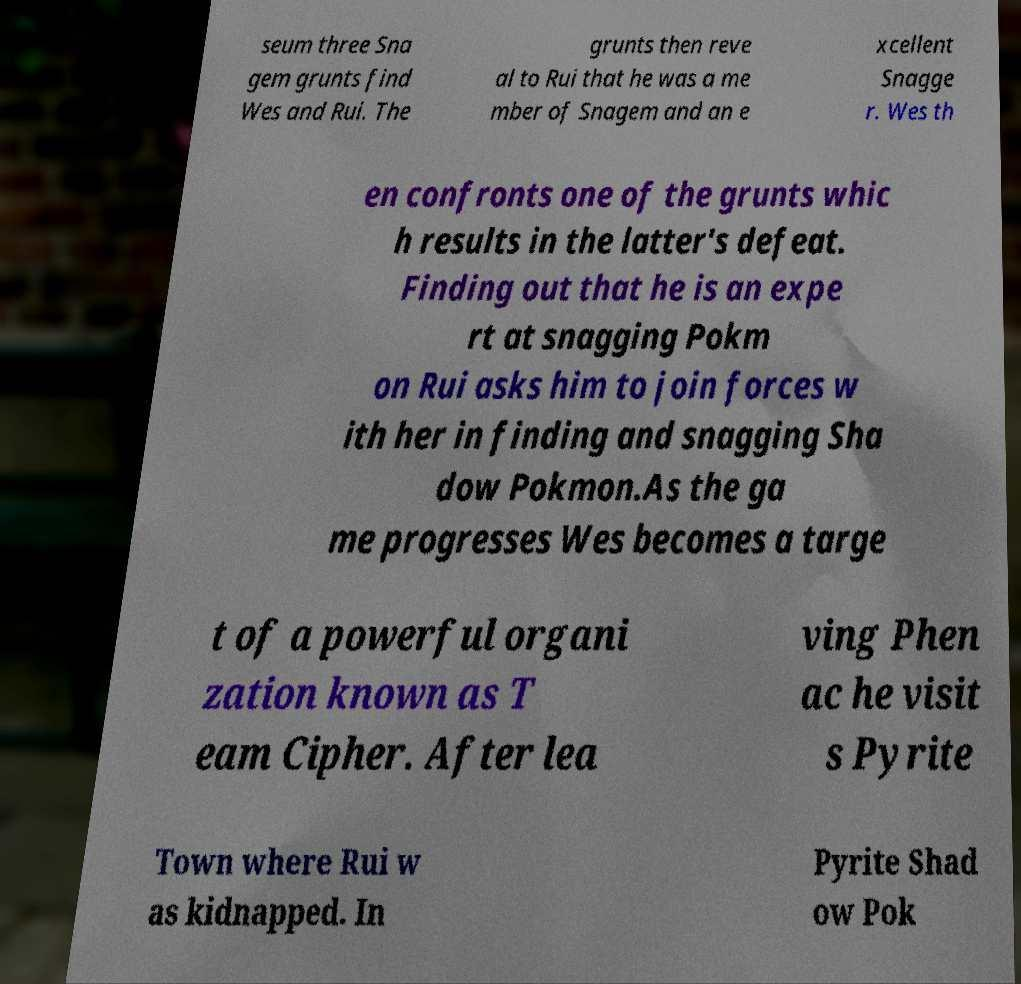I need the written content from this picture converted into text. Can you do that? seum three Sna gem grunts find Wes and Rui. The grunts then reve al to Rui that he was a me mber of Snagem and an e xcellent Snagge r. Wes th en confronts one of the grunts whic h results in the latter's defeat. Finding out that he is an expe rt at snagging Pokm on Rui asks him to join forces w ith her in finding and snagging Sha dow Pokmon.As the ga me progresses Wes becomes a targe t of a powerful organi zation known as T eam Cipher. After lea ving Phen ac he visit s Pyrite Town where Rui w as kidnapped. In Pyrite Shad ow Pok 